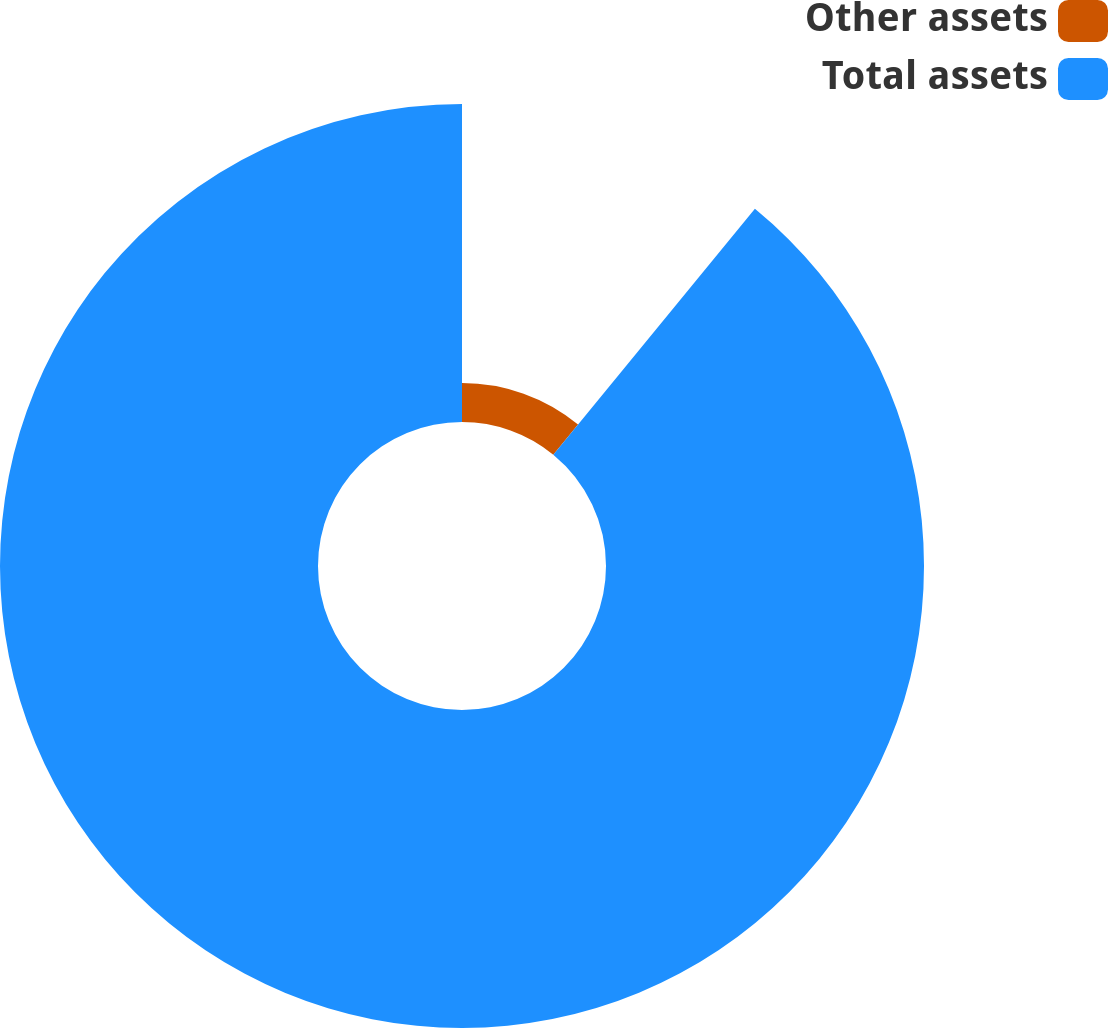<chart> <loc_0><loc_0><loc_500><loc_500><pie_chart><fcel>Other assets<fcel>Total assets<nl><fcel>10.93%<fcel>89.07%<nl></chart> 